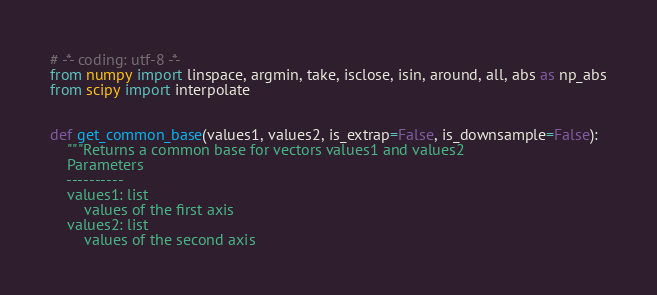Convert code to text. <code><loc_0><loc_0><loc_500><loc_500><_Python_># -*- coding: utf-8 -*-
from numpy import linspace, argmin, take, isclose, isin, around, all, abs as np_abs
from scipy import interpolate


def get_common_base(values1, values2, is_extrap=False, is_downsample=False):
    """Returns a common base for vectors values1 and values2
    Parameters
    ----------
    values1: list
        values of the first axis
    values2: list
        values of the second axis</code> 